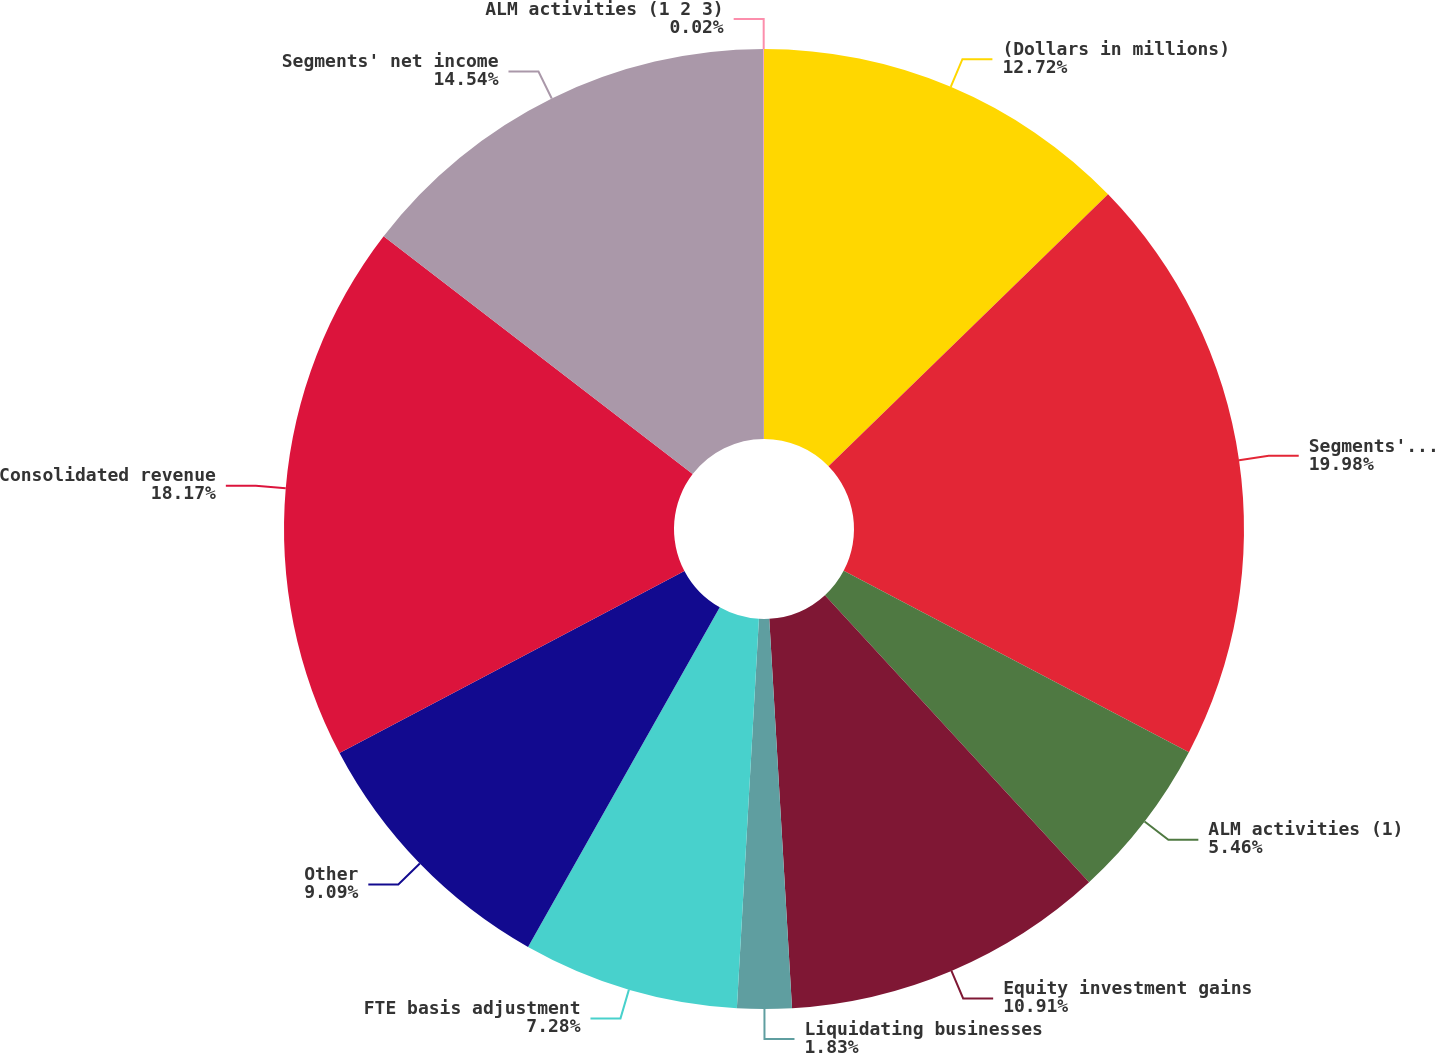<chart> <loc_0><loc_0><loc_500><loc_500><pie_chart><fcel>(Dollars in millions)<fcel>Segments' total revenue (FTE<fcel>ALM activities (1)<fcel>Equity investment gains<fcel>Liquidating businesses<fcel>FTE basis adjustment<fcel>Other<fcel>Consolidated revenue<fcel>Segments' net income<fcel>ALM activities (1 2 3)<nl><fcel>12.72%<fcel>19.98%<fcel>5.46%<fcel>10.91%<fcel>1.83%<fcel>7.28%<fcel>9.09%<fcel>18.17%<fcel>14.54%<fcel>0.02%<nl></chart> 